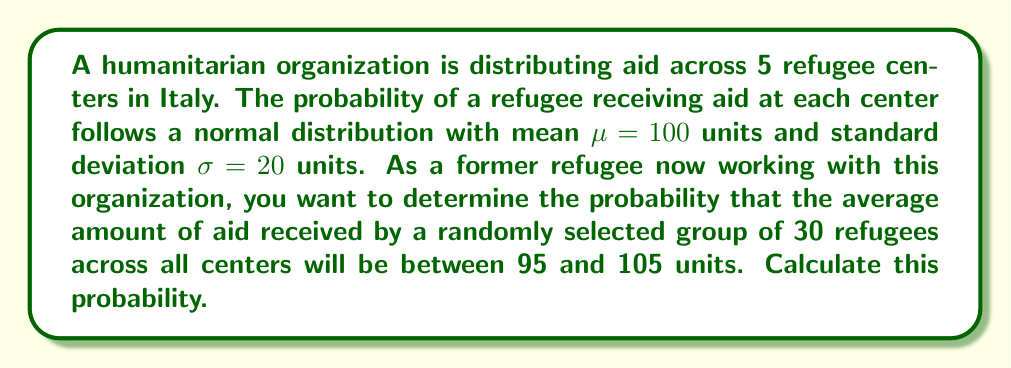Can you solve this math problem? Let's approach this step-by-step:

1) First, we need to understand what we're dealing with. We have:
   - 5 refugee centers
   - Normal distribution of aid at each center with $\mu = 100$ and $\sigma = 20$
   - Sample size of 30 refugees

2) We're asked about the average amount of aid for 30 refugees. This calls for the Central Limit Theorem (CLT).

3) According to the CLT, for a large sample size (generally n > 30, but 30 is often considered sufficient), the sampling distribution of the mean follows a normal distribution with:

   $\mu_{\bar{X}} = \mu$ (same as the population mean)
   $\sigma_{\bar{X}} = \frac{\sigma}{\sqrt{n}}$ (standard error of the mean)

4) In our case:
   $\mu_{\bar{X}} = 100$
   $\sigma_{\bar{X}} = \frac{20}{\sqrt{30}} = \frac{20}{\sqrt{30}} \approx 3.65$

5) Now, we need to find P(95 < $\bar{X}$ < 105)

6) To use the standard normal distribution, we need to standardize these values:

   $z_1 = \frac{95 - 100}{3.65} \approx -1.37$
   $z_2 = \frac{105 - 100}{3.65} \approx 1.37$

7) Now we need to find P(-1.37 < Z < 1.37)

8) Using the standard normal distribution table or a calculator:

   P(Z < 1.37) = 0.9147
   P(Z < -1.37) = 1 - 0.9147 = 0.0853

9) The probability we're looking for is:

   P(-1.37 < Z < 1.37) = 0.9147 - 0.0853 = 0.8294

Therefore, the probability that the average amount of aid received by a randomly selected group of 30 refugees will be between 95 and 105 units is approximately 0.8294 or 82.94%.
Answer: 0.8294 or 82.94% 